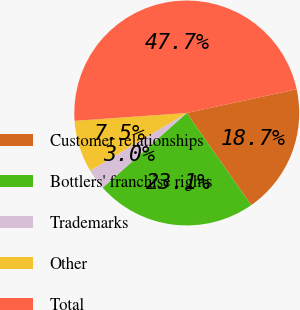Convert chart to OTSL. <chart><loc_0><loc_0><loc_500><loc_500><pie_chart><fcel>Customer relationships<fcel>Bottlers' franchise rights<fcel>Trademarks<fcel>Other<fcel>Total<nl><fcel>18.67%<fcel>23.15%<fcel>2.99%<fcel>7.46%<fcel>47.73%<nl></chart> 